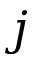<formula> <loc_0><loc_0><loc_500><loc_500>j</formula> 